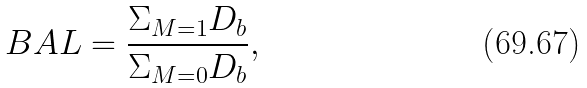Convert formula to latex. <formula><loc_0><loc_0><loc_500><loc_500>B A L = \frac { \Sigma _ { M = 1 } D _ { b } } { \Sigma _ { M = 0 } D _ { b } } ,</formula> 